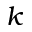Convert formula to latex. <formula><loc_0><loc_0><loc_500><loc_500>k</formula> 